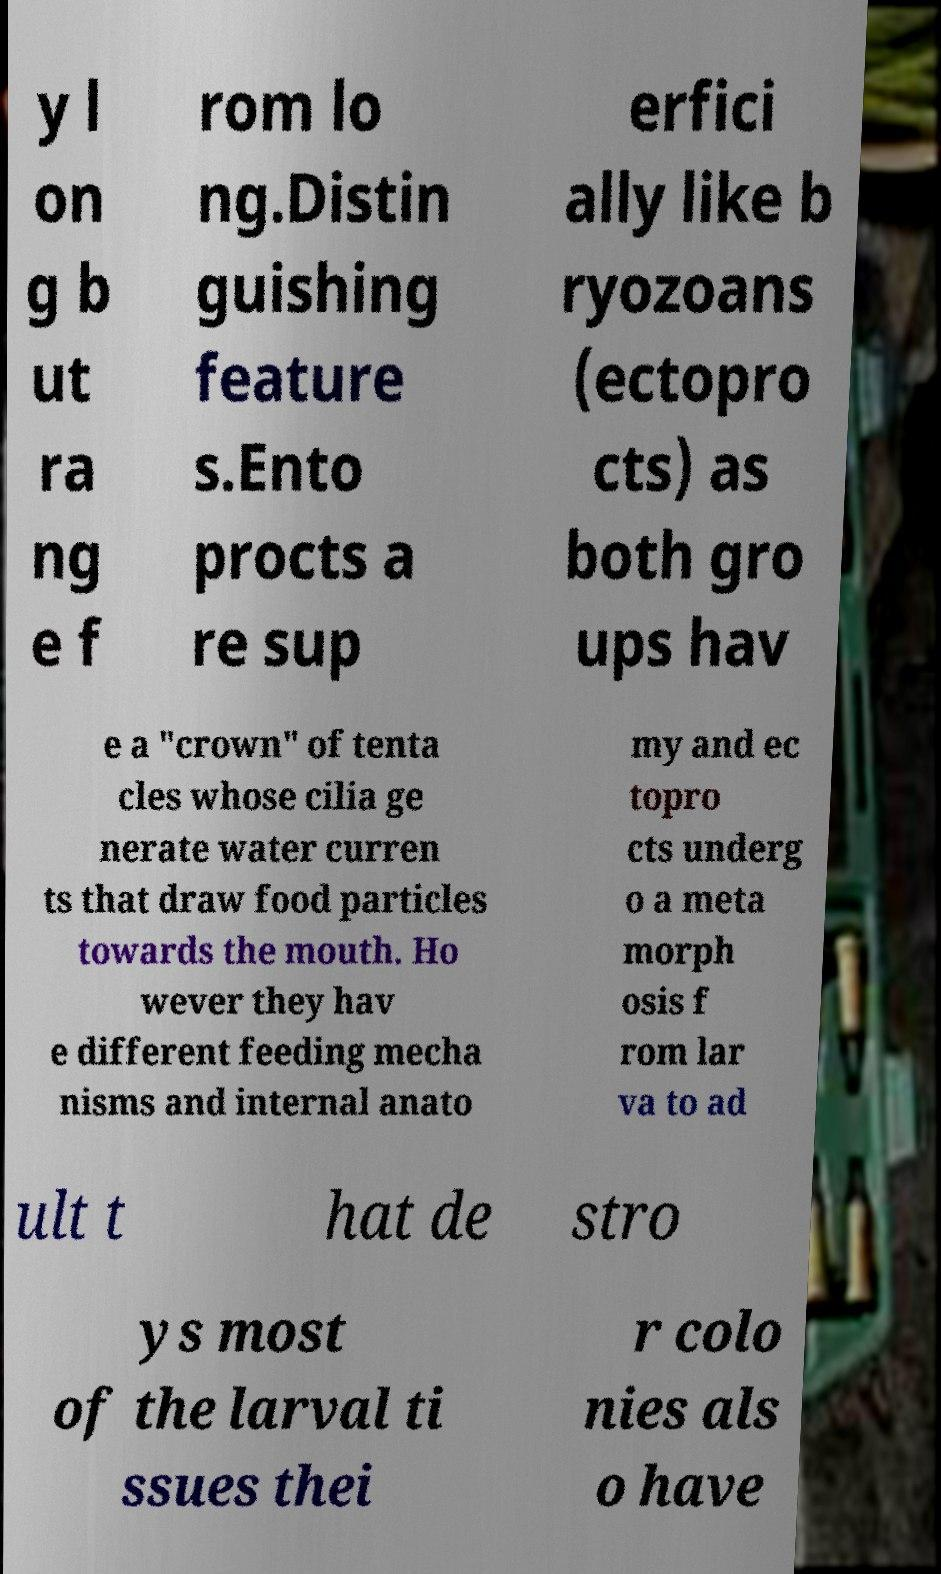Can you accurately transcribe the text from the provided image for me? y l on g b ut ra ng e f rom lo ng.Distin guishing feature s.Ento procts a re sup erfici ally like b ryozoans (ectopro cts) as both gro ups hav e a "crown" of tenta cles whose cilia ge nerate water curren ts that draw food particles towards the mouth. Ho wever they hav e different feeding mecha nisms and internal anato my and ec topro cts underg o a meta morph osis f rom lar va to ad ult t hat de stro ys most of the larval ti ssues thei r colo nies als o have 